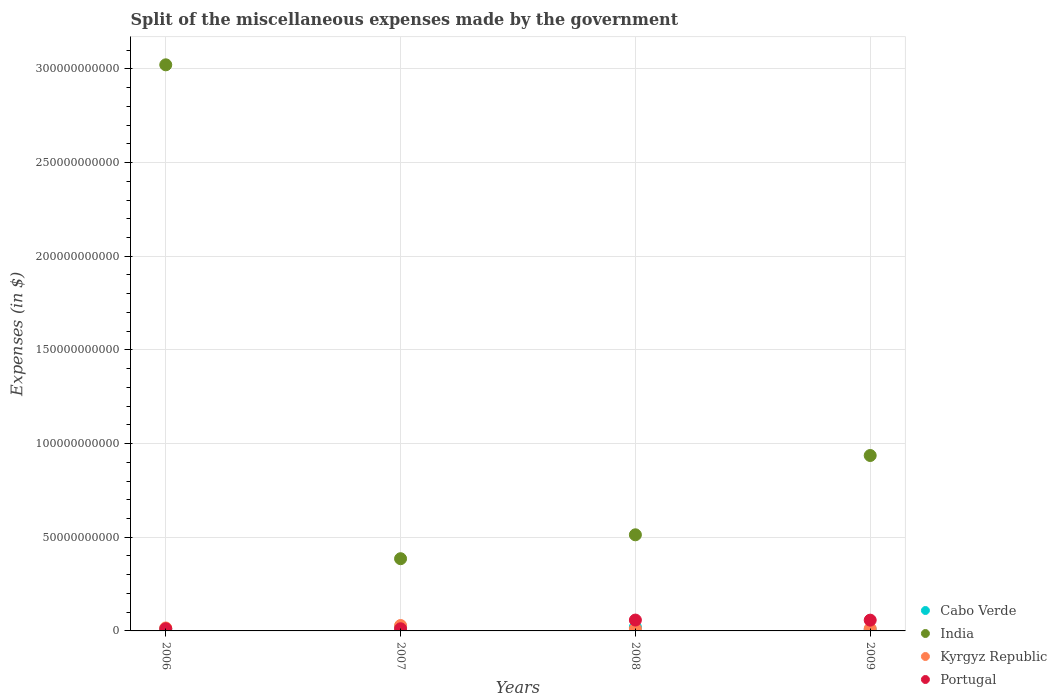Is the number of dotlines equal to the number of legend labels?
Keep it short and to the point. Yes. What is the miscellaneous expenses made by the government in Cabo Verde in 2009?
Keep it short and to the point. 6.89e+08. Across all years, what is the maximum miscellaneous expenses made by the government in Cabo Verde?
Your answer should be compact. 2.01e+09. Across all years, what is the minimum miscellaneous expenses made by the government in Kyrgyz Republic?
Give a very brief answer. 1.08e+09. In which year was the miscellaneous expenses made by the government in Cabo Verde maximum?
Keep it short and to the point. 2008. In which year was the miscellaneous expenses made by the government in Cabo Verde minimum?
Your answer should be compact. 2009. What is the total miscellaneous expenses made by the government in Kyrgyz Republic in the graph?
Ensure brevity in your answer.  6.76e+09. What is the difference between the miscellaneous expenses made by the government in Kyrgyz Republic in 2008 and that in 2009?
Provide a short and direct response. -1.43e+08. What is the difference between the miscellaneous expenses made by the government in India in 2006 and the miscellaneous expenses made by the government in Cabo Verde in 2009?
Your answer should be very brief. 3.02e+11. What is the average miscellaneous expenses made by the government in Portugal per year?
Your answer should be compact. 3.47e+09. In the year 2006, what is the difference between the miscellaneous expenses made by the government in India and miscellaneous expenses made by the government in Portugal?
Your response must be concise. 3.01e+11. In how many years, is the miscellaneous expenses made by the government in India greater than 290000000000 $?
Keep it short and to the point. 1. What is the ratio of the miscellaneous expenses made by the government in Kyrgyz Republic in 2006 to that in 2009?
Make the answer very short. 1.3. Is the miscellaneous expenses made by the government in India in 2006 less than that in 2008?
Your answer should be very brief. No. What is the difference between the highest and the second highest miscellaneous expenses made by the government in Portugal?
Ensure brevity in your answer.  4.37e+07. What is the difference between the highest and the lowest miscellaneous expenses made by the government in India?
Offer a terse response. 2.64e+11. In how many years, is the miscellaneous expenses made by the government in Cabo Verde greater than the average miscellaneous expenses made by the government in Cabo Verde taken over all years?
Your answer should be compact. 2. Is the sum of the miscellaneous expenses made by the government in Portugal in 2006 and 2009 greater than the maximum miscellaneous expenses made by the government in India across all years?
Your answer should be very brief. No. Is it the case that in every year, the sum of the miscellaneous expenses made by the government in India and miscellaneous expenses made by the government in Cabo Verde  is greater than the miscellaneous expenses made by the government in Kyrgyz Republic?
Provide a short and direct response. Yes. Does the miscellaneous expenses made by the government in India monotonically increase over the years?
Provide a short and direct response. No. How many dotlines are there?
Your response must be concise. 4. How many years are there in the graph?
Your answer should be compact. 4. What is the difference between two consecutive major ticks on the Y-axis?
Provide a short and direct response. 5.00e+1. Are the values on the major ticks of Y-axis written in scientific E-notation?
Provide a short and direct response. No. Does the graph contain any zero values?
Your answer should be very brief. No. Does the graph contain grids?
Your answer should be compact. Yes. Where does the legend appear in the graph?
Keep it short and to the point. Bottom right. How many legend labels are there?
Provide a short and direct response. 4. How are the legend labels stacked?
Ensure brevity in your answer.  Vertical. What is the title of the graph?
Your answer should be compact. Split of the miscellaneous expenses made by the government. Does "Argentina" appear as one of the legend labels in the graph?
Your response must be concise. No. What is the label or title of the X-axis?
Offer a very short reply. Years. What is the label or title of the Y-axis?
Provide a succinct answer. Expenses (in $). What is the Expenses (in $) of Cabo Verde in 2006?
Your answer should be very brief. 1.05e+09. What is the Expenses (in $) in India in 2006?
Make the answer very short. 3.02e+11. What is the Expenses (in $) of Kyrgyz Republic in 2006?
Give a very brief answer. 1.58e+09. What is the Expenses (in $) in Portugal in 2006?
Give a very brief answer. 1.16e+09. What is the Expenses (in $) in Cabo Verde in 2007?
Your answer should be very brief. 1.88e+09. What is the Expenses (in $) in India in 2007?
Offer a terse response. 3.86e+1. What is the Expenses (in $) of Kyrgyz Republic in 2007?
Provide a succinct answer. 2.88e+09. What is the Expenses (in $) in Portugal in 2007?
Ensure brevity in your answer.  1.16e+09. What is the Expenses (in $) in Cabo Verde in 2008?
Provide a short and direct response. 2.01e+09. What is the Expenses (in $) of India in 2008?
Offer a terse response. 5.13e+1. What is the Expenses (in $) of Kyrgyz Republic in 2008?
Your answer should be very brief. 1.08e+09. What is the Expenses (in $) of Portugal in 2008?
Your answer should be very brief. 5.80e+09. What is the Expenses (in $) of Cabo Verde in 2009?
Provide a short and direct response. 6.89e+08. What is the Expenses (in $) of India in 2009?
Give a very brief answer. 9.36e+1. What is the Expenses (in $) of Kyrgyz Republic in 2009?
Keep it short and to the point. 1.22e+09. What is the Expenses (in $) in Portugal in 2009?
Provide a short and direct response. 5.75e+09. Across all years, what is the maximum Expenses (in $) in Cabo Verde?
Provide a succinct answer. 2.01e+09. Across all years, what is the maximum Expenses (in $) in India?
Provide a short and direct response. 3.02e+11. Across all years, what is the maximum Expenses (in $) of Kyrgyz Republic?
Your answer should be compact. 2.88e+09. Across all years, what is the maximum Expenses (in $) in Portugal?
Make the answer very short. 5.80e+09. Across all years, what is the minimum Expenses (in $) of Cabo Verde?
Make the answer very short. 6.89e+08. Across all years, what is the minimum Expenses (in $) in India?
Offer a very short reply. 3.86e+1. Across all years, what is the minimum Expenses (in $) in Kyrgyz Republic?
Your answer should be compact. 1.08e+09. Across all years, what is the minimum Expenses (in $) in Portugal?
Make the answer very short. 1.16e+09. What is the total Expenses (in $) in Cabo Verde in the graph?
Offer a very short reply. 5.63e+09. What is the total Expenses (in $) of India in the graph?
Give a very brief answer. 4.86e+11. What is the total Expenses (in $) of Kyrgyz Republic in the graph?
Give a very brief answer. 6.76e+09. What is the total Expenses (in $) of Portugal in the graph?
Provide a succinct answer. 1.39e+1. What is the difference between the Expenses (in $) of Cabo Verde in 2006 and that in 2007?
Make the answer very short. -8.30e+08. What is the difference between the Expenses (in $) in India in 2006 and that in 2007?
Provide a short and direct response. 2.64e+11. What is the difference between the Expenses (in $) of Kyrgyz Republic in 2006 and that in 2007?
Provide a short and direct response. -1.30e+09. What is the difference between the Expenses (in $) in Portugal in 2006 and that in 2007?
Give a very brief answer. -2.93e+06. What is the difference between the Expenses (in $) in Cabo Verde in 2006 and that in 2008?
Keep it short and to the point. -9.66e+08. What is the difference between the Expenses (in $) in India in 2006 and that in 2008?
Provide a short and direct response. 2.51e+11. What is the difference between the Expenses (in $) in Kyrgyz Republic in 2006 and that in 2008?
Make the answer very short. 5.04e+08. What is the difference between the Expenses (in $) in Portugal in 2006 and that in 2008?
Make the answer very short. -4.64e+09. What is the difference between the Expenses (in $) of Cabo Verde in 2006 and that in 2009?
Give a very brief answer. 3.58e+08. What is the difference between the Expenses (in $) in India in 2006 and that in 2009?
Your answer should be compact. 2.09e+11. What is the difference between the Expenses (in $) of Kyrgyz Republic in 2006 and that in 2009?
Keep it short and to the point. 3.60e+08. What is the difference between the Expenses (in $) of Portugal in 2006 and that in 2009?
Keep it short and to the point. -4.60e+09. What is the difference between the Expenses (in $) of Cabo Verde in 2007 and that in 2008?
Provide a succinct answer. -1.36e+08. What is the difference between the Expenses (in $) of India in 2007 and that in 2008?
Your answer should be very brief. -1.28e+1. What is the difference between the Expenses (in $) of Kyrgyz Republic in 2007 and that in 2008?
Offer a very short reply. 1.80e+09. What is the difference between the Expenses (in $) in Portugal in 2007 and that in 2008?
Your response must be concise. -4.64e+09. What is the difference between the Expenses (in $) in Cabo Verde in 2007 and that in 2009?
Give a very brief answer. 1.19e+09. What is the difference between the Expenses (in $) of India in 2007 and that in 2009?
Your answer should be compact. -5.51e+1. What is the difference between the Expenses (in $) of Kyrgyz Republic in 2007 and that in 2009?
Provide a succinct answer. 1.66e+09. What is the difference between the Expenses (in $) of Portugal in 2007 and that in 2009?
Give a very brief answer. -4.59e+09. What is the difference between the Expenses (in $) in Cabo Verde in 2008 and that in 2009?
Offer a terse response. 1.32e+09. What is the difference between the Expenses (in $) of India in 2008 and that in 2009?
Your answer should be very brief. -4.23e+1. What is the difference between the Expenses (in $) of Kyrgyz Republic in 2008 and that in 2009?
Offer a very short reply. -1.43e+08. What is the difference between the Expenses (in $) of Portugal in 2008 and that in 2009?
Keep it short and to the point. 4.37e+07. What is the difference between the Expenses (in $) in Cabo Verde in 2006 and the Expenses (in $) in India in 2007?
Your answer should be very brief. -3.75e+1. What is the difference between the Expenses (in $) of Cabo Verde in 2006 and the Expenses (in $) of Kyrgyz Republic in 2007?
Provide a short and direct response. -1.83e+09. What is the difference between the Expenses (in $) in Cabo Verde in 2006 and the Expenses (in $) in Portugal in 2007?
Provide a succinct answer. -1.12e+08. What is the difference between the Expenses (in $) of India in 2006 and the Expenses (in $) of Kyrgyz Republic in 2007?
Your answer should be very brief. 2.99e+11. What is the difference between the Expenses (in $) in India in 2006 and the Expenses (in $) in Portugal in 2007?
Make the answer very short. 3.01e+11. What is the difference between the Expenses (in $) of Kyrgyz Republic in 2006 and the Expenses (in $) of Portugal in 2007?
Your response must be concise. 4.23e+08. What is the difference between the Expenses (in $) in Cabo Verde in 2006 and the Expenses (in $) in India in 2008?
Your response must be concise. -5.03e+1. What is the difference between the Expenses (in $) in Cabo Verde in 2006 and the Expenses (in $) in Kyrgyz Republic in 2008?
Your answer should be very brief. -3.02e+07. What is the difference between the Expenses (in $) of Cabo Verde in 2006 and the Expenses (in $) of Portugal in 2008?
Provide a short and direct response. -4.75e+09. What is the difference between the Expenses (in $) in India in 2006 and the Expenses (in $) in Kyrgyz Republic in 2008?
Your answer should be compact. 3.01e+11. What is the difference between the Expenses (in $) of India in 2006 and the Expenses (in $) of Portugal in 2008?
Keep it short and to the point. 2.96e+11. What is the difference between the Expenses (in $) of Kyrgyz Republic in 2006 and the Expenses (in $) of Portugal in 2008?
Your answer should be compact. -4.21e+09. What is the difference between the Expenses (in $) of Cabo Verde in 2006 and the Expenses (in $) of India in 2009?
Offer a very short reply. -9.26e+1. What is the difference between the Expenses (in $) of Cabo Verde in 2006 and the Expenses (in $) of Kyrgyz Republic in 2009?
Your response must be concise. -1.74e+08. What is the difference between the Expenses (in $) in Cabo Verde in 2006 and the Expenses (in $) in Portugal in 2009?
Your response must be concise. -4.71e+09. What is the difference between the Expenses (in $) in India in 2006 and the Expenses (in $) in Kyrgyz Republic in 2009?
Provide a succinct answer. 3.01e+11. What is the difference between the Expenses (in $) in India in 2006 and the Expenses (in $) in Portugal in 2009?
Your answer should be compact. 2.96e+11. What is the difference between the Expenses (in $) in Kyrgyz Republic in 2006 and the Expenses (in $) in Portugal in 2009?
Your response must be concise. -4.17e+09. What is the difference between the Expenses (in $) of Cabo Verde in 2007 and the Expenses (in $) of India in 2008?
Provide a succinct answer. -4.94e+1. What is the difference between the Expenses (in $) in Cabo Verde in 2007 and the Expenses (in $) in Kyrgyz Republic in 2008?
Provide a short and direct response. 8.00e+08. What is the difference between the Expenses (in $) of Cabo Verde in 2007 and the Expenses (in $) of Portugal in 2008?
Make the answer very short. -3.92e+09. What is the difference between the Expenses (in $) in India in 2007 and the Expenses (in $) in Kyrgyz Republic in 2008?
Keep it short and to the point. 3.75e+1. What is the difference between the Expenses (in $) in India in 2007 and the Expenses (in $) in Portugal in 2008?
Make the answer very short. 3.28e+1. What is the difference between the Expenses (in $) in Kyrgyz Republic in 2007 and the Expenses (in $) in Portugal in 2008?
Provide a succinct answer. -2.91e+09. What is the difference between the Expenses (in $) in Cabo Verde in 2007 and the Expenses (in $) in India in 2009?
Keep it short and to the point. -9.18e+1. What is the difference between the Expenses (in $) of Cabo Verde in 2007 and the Expenses (in $) of Kyrgyz Republic in 2009?
Offer a very short reply. 6.57e+08. What is the difference between the Expenses (in $) of Cabo Verde in 2007 and the Expenses (in $) of Portugal in 2009?
Your answer should be compact. -3.87e+09. What is the difference between the Expenses (in $) in India in 2007 and the Expenses (in $) in Kyrgyz Republic in 2009?
Offer a very short reply. 3.73e+1. What is the difference between the Expenses (in $) in India in 2007 and the Expenses (in $) in Portugal in 2009?
Offer a very short reply. 3.28e+1. What is the difference between the Expenses (in $) in Kyrgyz Republic in 2007 and the Expenses (in $) in Portugal in 2009?
Offer a very short reply. -2.87e+09. What is the difference between the Expenses (in $) in Cabo Verde in 2008 and the Expenses (in $) in India in 2009?
Your response must be concise. -9.16e+1. What is the difference between the Expenses (in $) in Cabo Verde in 2008 and the Expenses (in $) in Kyrgyz Republic in 2009?
Give a very brief answer. 7.93e+08. What is the difference between the Expenses (in $) in Cabo Verde in 2008 and the Expenses (in $) in Portugal in 2009?
Your response must be concise. -3.74e+09. What is the difference between the Expenses (in $) in India in 2008 and the Expenses (in $) in Kyrgyz Republic in 2009?
Offer a very short reply. 5.01e+1. What is the difference between the Expenses (in $) in India in 2008 and the Expenses (in $) in Portugal in 2009?
Make the answer very short. 4.56e+1. What is the difference between the Expenses (in $) in Kyrgyz Republic in 2008 and the Expenses (in $) in Portugal in 2009?
Ensure brevity in your answer.  -4.67e+09. What is the average Expenses (in $) of Cabo Verde per year?
Offer a very short reply. 1.41e+09. What is the average Expenses (in $) in India per year?
Your answer should be compact. 1.21e+11. What is the average Expenses (in $) in Kyrgyz Republic per year?
Ensure brevity in your answer.  1.69e+09. What is the average Expenses (in $) of Portugal per year?
Keep it short and to the point. 3.47e+09. In the year 2006, what is the difference between the Expenses (in $) in Cabo Verde and Expenses (in $) in India?
Give a very brief answer. -3.01e+11. In the year 2006, what is the difference between the Expenses (in $) of Cabo Verde and Expenses (in $) of Kyrgyz Republic?
Provide a succinct answer. -5.34e+08. In the year 2006, what is the difference between the Expenses (in $) in Cabo Verde and Expenses (in $) in Portugal?
Provide a succinct answer. -1.09e+08. In the year 2006, what is the difference between the Expenses (in $) of India and Expenses (in $) of Kyrgyz Republic?
Offer a very short reply. 3.01e+11. In the year 2006, what is the difference between the Expenses (in $) of India and Expenses (in $) of Portugal?
Give a very brief answer. 3.01e+11. In the year 2006, what is the difference between the Expenses (in $) in Kyrgyz Republic and Expenses (in $) in Portugal?
Your answer should be very brief. 4.25e+08. In the year 2007, what is the difference between the Expenses (in $) of Cabo Verde and Expenses (in $) of India?
Your answer should be compact. -3.67e+1. In the year 2007, what is the difference between the Expenses (in $) in Cabo Verde and Expenses (in $) in Kyrgyz Republic?
Your response must be concise. -1.00e+09. In the year 2007, what is the difference between the Expenses (in $) of Cabo Verde and Expenses (in $) of Portugal?
Provide a succinct answer. 7.19e+08. In the year 2007, what is the difference between the Expenses (in $) in India and Expenses (in $) in Kyrgyz Republic?
Keep it short and to the point. 3.57e+1. In the year 2007, what is the difference between the Expenses (in $) in India and Expenses (in $) in Portugal?
Provide a succinct answer. 3.74e+1. In the year 2007, what is the difference between the Expenses (in $) in Kyrgyz Republic and Expenses (in $) in Portugal?
Make the answer very short. 1.72e+09. In the year 2008, what is the difference between the Expenses (in $) of Cabo Verde and Expenses (in $) of India?
Offer a terse response. -4.93e+1. In the year 2008, what is the difference between the Expenses (in $) in Cabo Verde and Expenses (in $) in Kyrgyz Republic?
Offer a very short reply. 9.36e+08. In the year 2008, what is the difference between the Expenses (in $) in Cabo Verde and Expenses (in $) in Portugal?
Give a very brief answer. -3.78e+09. In the year 2008, what is the difference between the Expenses (in $) in India and Expenses (in $) in Kyrgyz Republic?
Offer a very short reply. 5.02e+1. In the year 2008, what is the difference between the Expenses (in $) in India and Expenses (in $) in Portugal?
Offer a very short reply. 4.55e+1. In the year 2008, what is the difference between the Expenses (in $) of Kyrgyz Republic and Expenses (in $) of Portugal?
Provide a succinct answer. -4.72e+09. In the year 2009, what is the difference between the Expenses (in $) of Cabo Verde and Expenses (in $) of India?
Provide a short and direct response. -9.30e+1. In the year 2009, what is the difference between the Expenses (in $) of Cabo Verde and Expenses (in $) of Kyrgyz Republic?
Your response must be concise. -5.31e+08. In the year 2009, what is the difference between the Expenses (in $) in Cabo Verde and Expenses (in $) in Portugal?
Make the answer very short. -5.06e+09. In the year 2009, what is the difference between the Expenses (in $) in India and Expenses (in $) in Kyrgyz Republic?
Keep it short and to the point. 9.24e+1. In the year 2009, what is the difference between the Expenses (in $) in India and Expenses (in $) in Portugal?
Provide a succinct answer. 8.79e+1. In the year 2009, what is the difference between the Expenses (in $) of Kyrgyz Republic and Expenses (in $) of Portugal?
Your response must be concise. -4.53e+09. What is the ratio of the Expenses (in $) in Cabo Verde in 2006 to that in 2007?
Make the answer very short. 0.56. What is the ratio of the Expenses (in $) of India in 2006 to that in 2007?
Your response must be concise. 7.84. What is the ratio of the Expenses (in $) in Kyrgyz Republic in 2006 to that in 2007?
Ensure brevity in your answer.  0.55. What is the ratio of the Expenses (in $) of Cabo Verde in 2006 to that in 2008?
Offer a terse response. 0.52. What is the ratio of the Expenses (in $) of India in 2006 to that in 2008?
Offer a terse response. 5.89. What is the ratio of the Expenses (in $) of Kyrgyz Republic in 2006 to that in 2008?
Provide a succinct answer. 1.47. What is the ratio of the Expenses (in $) in Portugal in 2006 to that in 2008?
Ensure brevity in your answer.  0.2. What is the ratio of the Expenses (in $) in Cabo Verde in 2006 to that in 2009?
Provide a short and direct response. 1.52. What is the ratio of the Expenses (in $) of India in 2006 to that in 2009?
Provide a succinct answer. 3.23. What is the ratio of the Expenses (in $) of Kyrgyz Republic in 2006 to that in 2009?
Offer a very short reply. 1.3. What is the ratio of the Expenses (in $) of Portugal in 2006 to that in 2009?
Your answer should be very brief. 0.2. What is the ratio of the Expenses (in $) of Cabo Verde in 2007 to that in 2008?
Offer a terse response. 0.93. What is the ratio of the Expenses (in $) of India in 2007 to that in 2008?
Make the answer very short. 0.75. What is the ratio of the Expenses (in $) of Kyrgyz Republic in 2007 to that in 2008?
Your response must be concise. 2.68. What is the ratio of the Expenses (in $) of Portugal in 2007 to that in 2008?
Offer a terse response. 0.2. What is the ratio of the Expenses (in $) in Cabo Verde in 2007 to that in 2009?
Provide a succinct answer. 2.72. What is the ratio of the Expenses (in $) of India in 2007 to that in 2009?
Your answer should be compact. 0.41. What is the ratio of the Expenses (in $) in Kyrgyz Republic in 2007 to that in 2009?
Offer a terse response. 2.36. What is the ratio of the Expenses (in $) of Portugal in 2007 to that in 2009?
Your response must be concise. 0.2. What is the ratio of the Expenses (in $) of Cabo Verde in 2008 to that in 2009?
Your response must be concise. 2.92. What is the ratio of the Expenses (in $) of India in 2008 to that in 2009?
Keep it short and to the point. 0.55. What is the ratio of the Expenses (in $) of Kyrgyz Republic in 2008 to that in 2009?
Provide a succinct answer. 0.88. What is the ratio of the Expenses (in $) in Portugal in 2008 to that in 2009?
Give a very brief answer. 1.01. What is the difference between the highest and the second highest Expenses (in $) of Cabo Verde?
Your response must be concise. 1.36e+08. What is the difference between the highest and the second highest Expenses (in $) of India?
Provide a short and direct response. 2.09e+11. What is the difference between the highest and the second highest Expenses (in $) in Kyrgyz Republic?
Your answer should be compact. 1.30e+09. What is the difference between the highest and the second highest Expenses (in $) of Portugal?
Provide a short and direct response. 4.37e+07. What is the difference between the highest and the lowest Expenses (in $) in Cabo Verde?
Ensure brevity in your answer.  1.32e+09. What is the difference between the highest and the lowest Expenses (in $) in India?
Your response must be concise. 2.64e+11. What is the difference between the highest and the lowest Expenses (in $) of Kyrgyz Republic?
Offer a very short reply. 1.80e+09. What is the difference between the highest and the lowest Expenses (in $) of Portugal?
Give a very brief answer. 4.64e+09. 